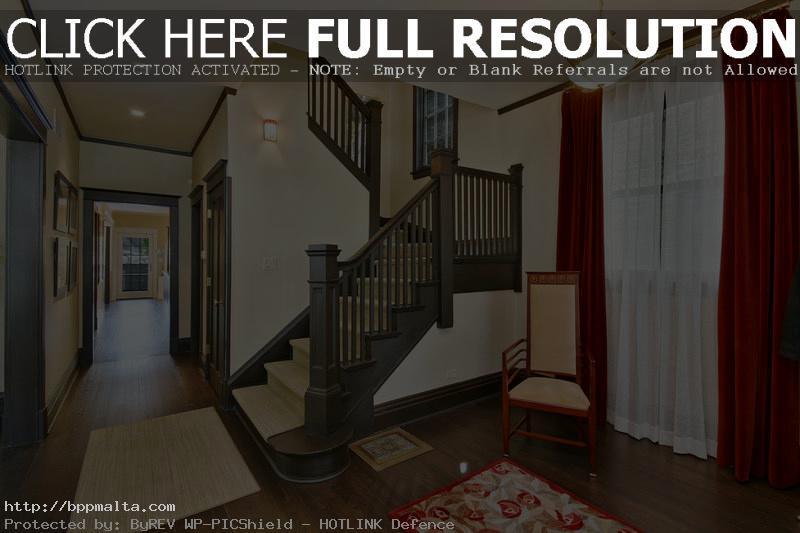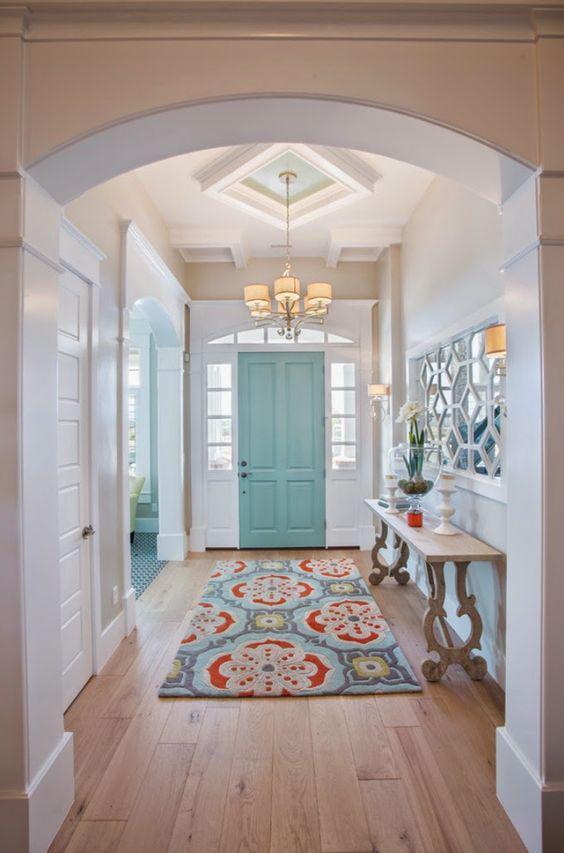The first image is the image on the left, the second image is the image on the right. Considering the images on both sides, is "One image contains two curved stairways with carpeted steps, white base boards, and brown handrails and balusters, and at least one of the stairways has white spindles." valid? Answer yes or no. No. 